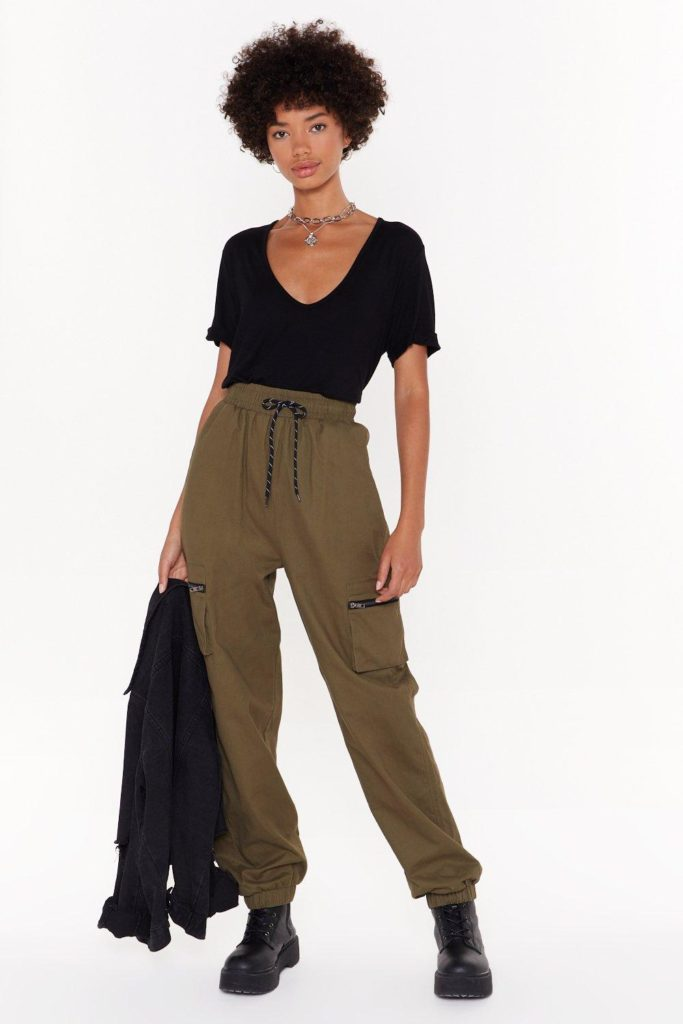Consider this individual is preparing for a day in the city. What could be their itinerary? For a day in the city, this individual's itinerary might start with a morning jog in the park, followed by a visit to a bustling café for a hearty breakfast and some work on their laptop. They might then explore a few local art galleries or see an exhibit at a nearby museum before heading to a trendy urban market to shop for artisanal goods and unique fashion pieces. After grabbing lunch at a hip, urban bistro, they could spend the afternoon attending meetings, window shopping in boutique stores, or taking a yoga class. The evening might be filled with plans to meet friends for dinner at a chic rooftop restaurant, followed by a visit to a contemporary live music performance or an open mic poetry reading. And a shorter version of their city plans? Their day in the city starts with coffee at a local café, moves on to a quick gallery visit, lunch at a stylish bistro, a bit of shopping, and ends with dinner and a live music performance. 